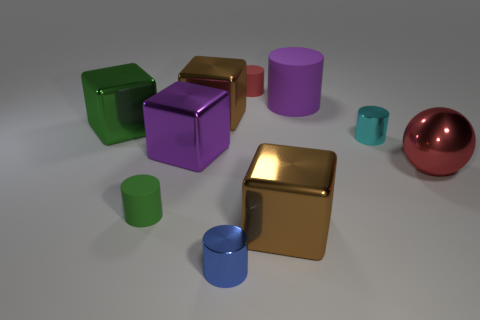Does the green rubber object have the same shape as the red shiny object?
Your answer should be compact. No. There is a green thing behind the purple thing that is to the left of the rubber thing that is behind the purple matte cylinder; what is its shape?
Make the answer very short. Cube. Is the color of the small cylinder that is behind the large green block the same as the thing right of the tiny cyan thing?
Your answer should be compact. Yes. There is a rubber thing that is the same color as the big sphere; what is its shape?
Keep it short and to the point. Cylinder. What number of rubber things are either tiny blue things or big gray objects?
Offer a very short reply. 0. The cylinder in front of the brown object that is in front of the thing on the right side of the tiny cyan metallic cylinder is what color?
Your response must be concise. Blue. What color is the other shiny object that is the same shape as the small blue metal object?
Your answer should be very brief. Cyan. How many other things are the same material as the small blue thing?
Provide a succinct answer. 6. The cyan metal thing has what size?
Your answer should be compact. Small. Is there a green metal thing that has the same shape as the large purple metal object?
Provide a short and direct response. Yes. 